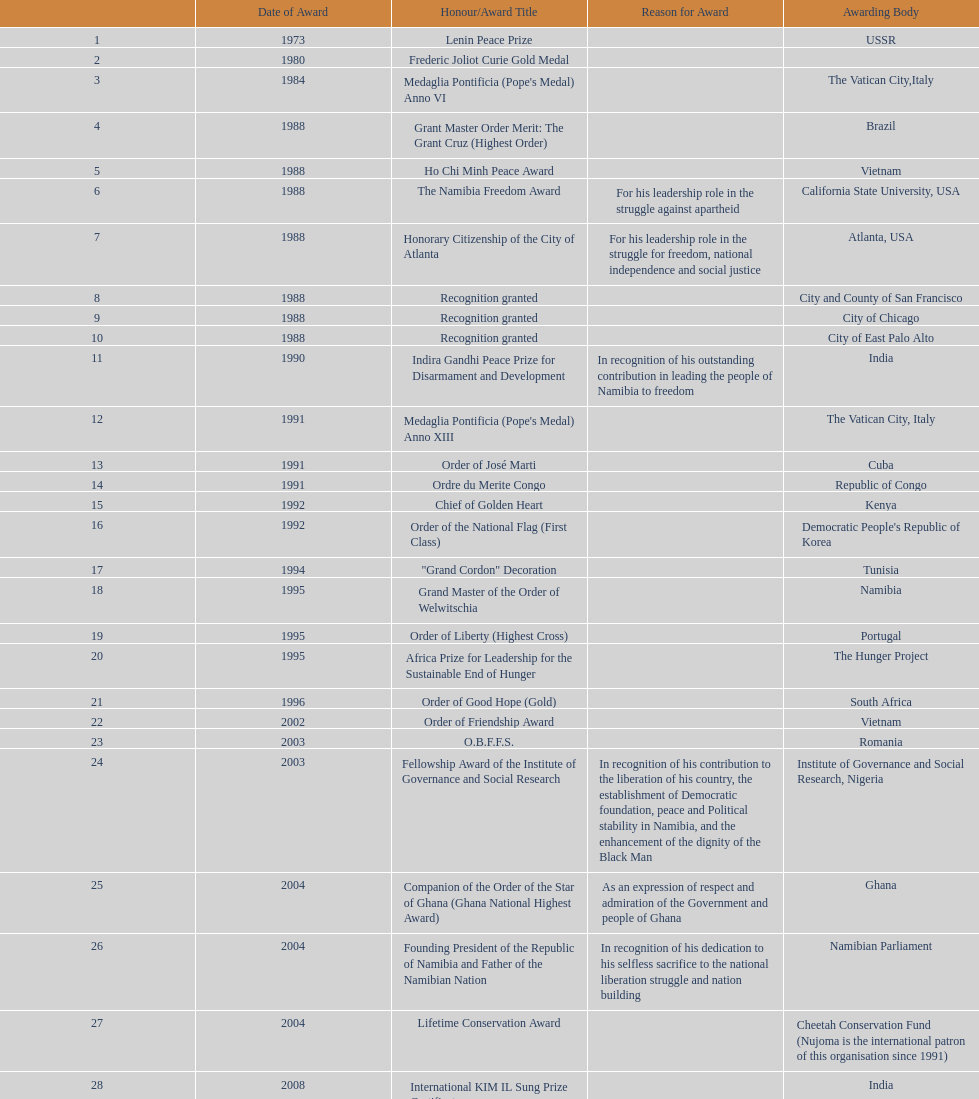Can you tell me the most recent honor that nujoma has achieved? Sir Seretse Khama SADC Meda. 